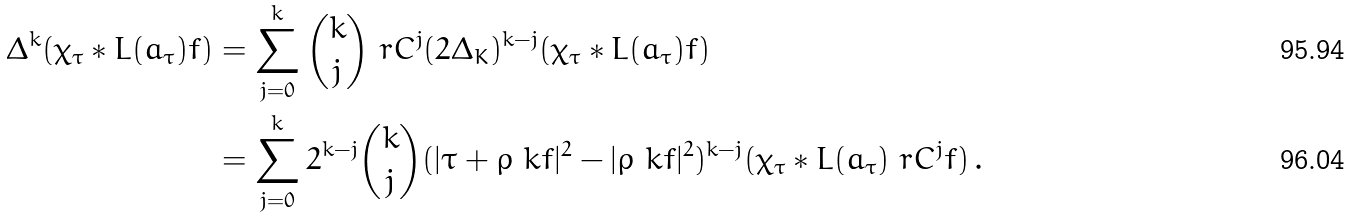Convert formula to latex. <formula><loc_0><loc_0><loc_500><loc_500>\Delta ^ { k } ( \chi _ { \tau } * L ( a _ { \tau } ) f ) & = \sum _ { j = 0 } ^ { k } { k \choose j } \ r C ^ { j } ( 2 \Delta _ { K } ) ^ { k - j } ( \chi _ { \tau } * L ( a _ { \tau } ) f ) \\ & = \sum _ { j = 0 } ^ { k } 2 ^ { k - j } { k \choose j } ( | \tau + \rho _ { \ } k f | ^ { 2 } - | \rho _ { \ } k f | ^ { 2 } ) ^ { k - j } ( \chi _ { \tau } * L ( a _ { \tau } ) \ r C ^ { j } f ) \, .</formula> 